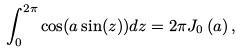<formula> <loc_0><loc_0><loc_500><loc_500>\int _ { 0 } ^ { 2 \pi } \cos ( a \sin ( z ) ) d z = 2 \pi J _ { 0 } \left ( a \right ) ,</formula> 